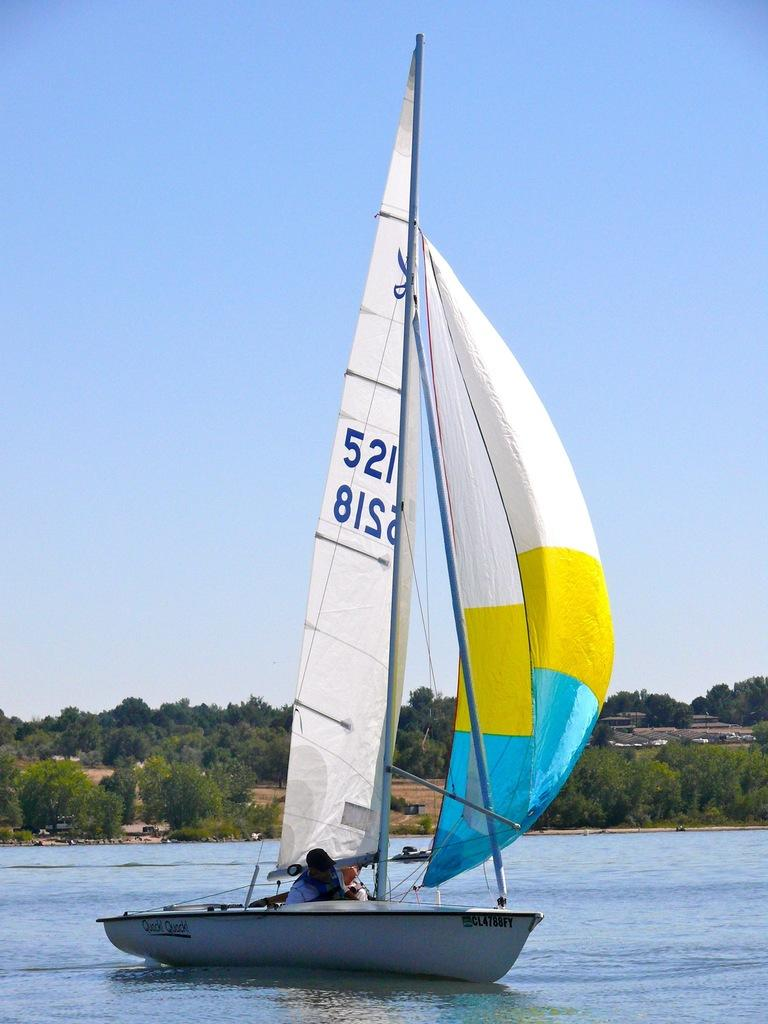What is the person in the image doing? The person is in a boat in the image. Where is the boat located? The boat is sailing on a river. What can be seen in the background of the image? There are trees, buildings, the ground, and the sky visible in the background of the image. What type of market can be seen in the background of the image? There is no market present in the image; the background features trees, buildings, the ground, and the sky. 